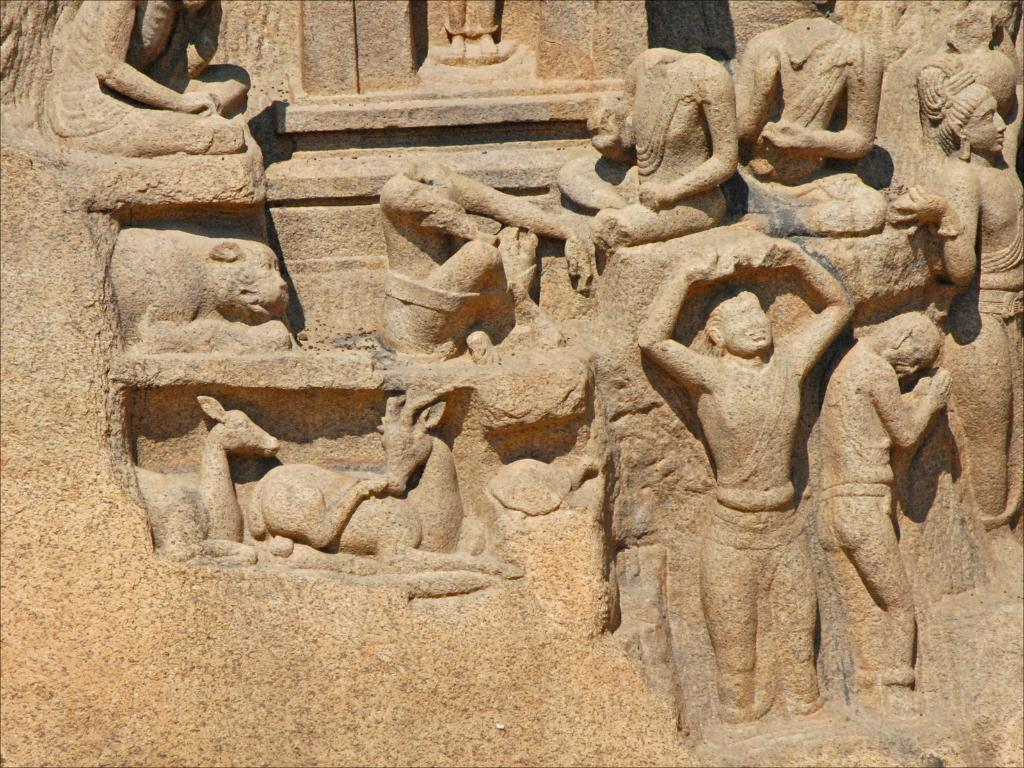What types of sculptures can be seen in the image? There are sculptures of people and animals in the image. Where are the sculptures located? The sculptures are on the wall. What letter is carved into the animal sculpture in the image? There is no letter carved into any of the sculptures in the image. 